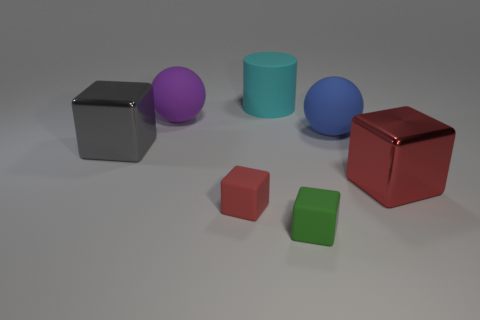Subtract all gray shiny cubes. How many cubes are left? 3 Add 2 large balls. How many objects exist? 9 Subtract all gray blocks. How many blocks are left? 3 Subtract all cylinders. How many objects are left? 6 Subtract 1 cubes. How many cubes are left? 3 Subtract all red blocks. Subtract all purple cylinders. How many blocks are left? 2 Subtract all gray cylinders. How many green blocks are left? 1 Subtract all large blue cylinders. Subtract all big gray metal things. How many objects are left? 6 Add 2 big blue objects. How many big blue objects are left? 3 Add 1 large cyan cylinders. How many large cyan cylinders exist? 2 